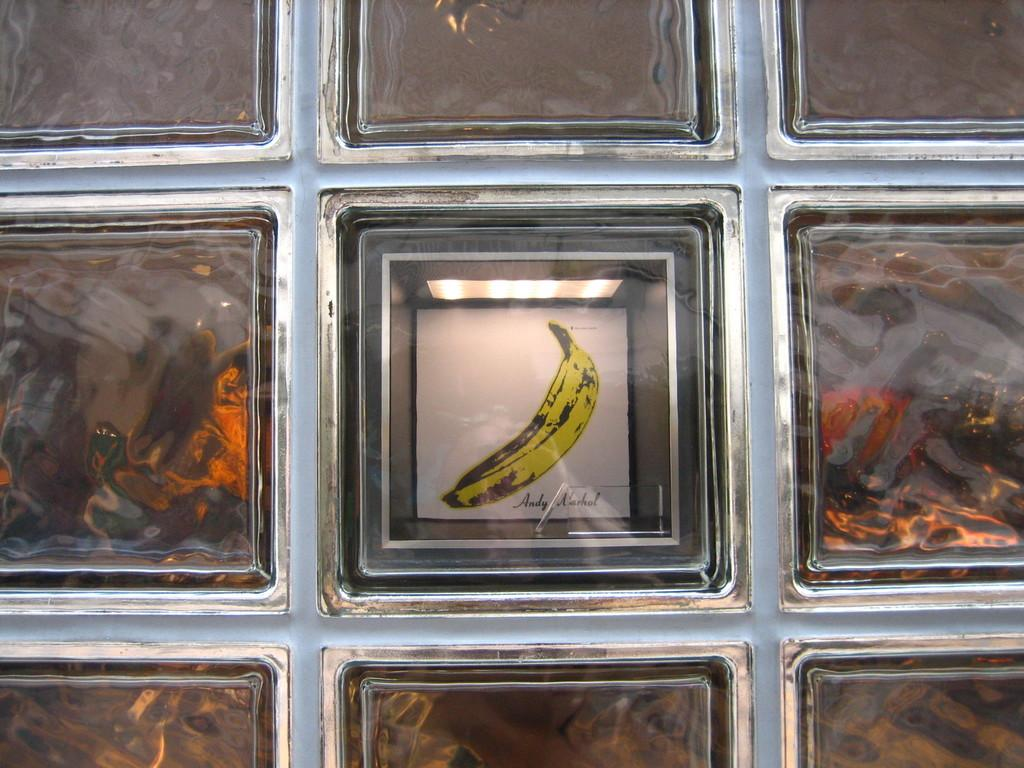What type of frame is visible in the image? There is a glass and steel frame in the image. What is displayed within the frame? Paintings and sketches are present in the frame. Where is the swing located in the image? There is no swing present in the image. What type of selection process is depicted in the image? The image does not depict a selection process; it features a glass and steel frame with paintings and sketches. 